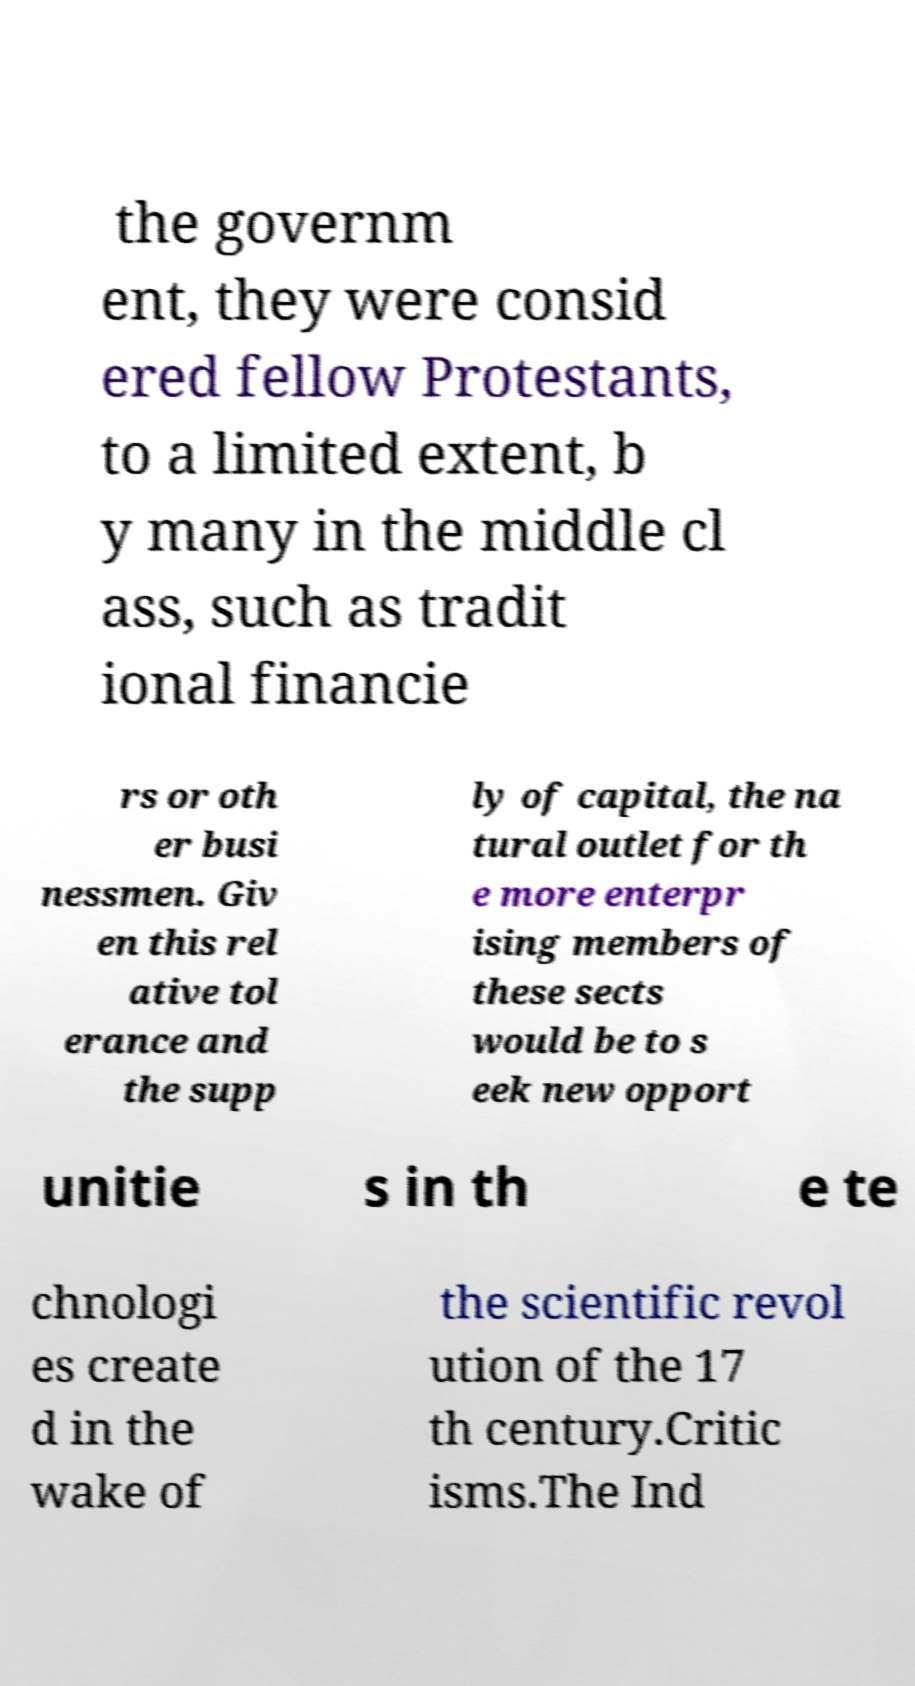I need the written content from this picture converted into text. Can you do that? the governm ent, they were consid ered fellow Protestants, to a limited extent, b y many in the middle cl ass, such as tradit ional financie rs or oth er busi nessmen. Giv en this rel ative tol erance and the supp ly of capital, the na tural outlet for th e more enterpr ising members of these sects would be to s eek new opport unitie s in th e te chnologi es create d in the wake of the scientific revol ution of the 17 th century.Critic isms.The Ind 